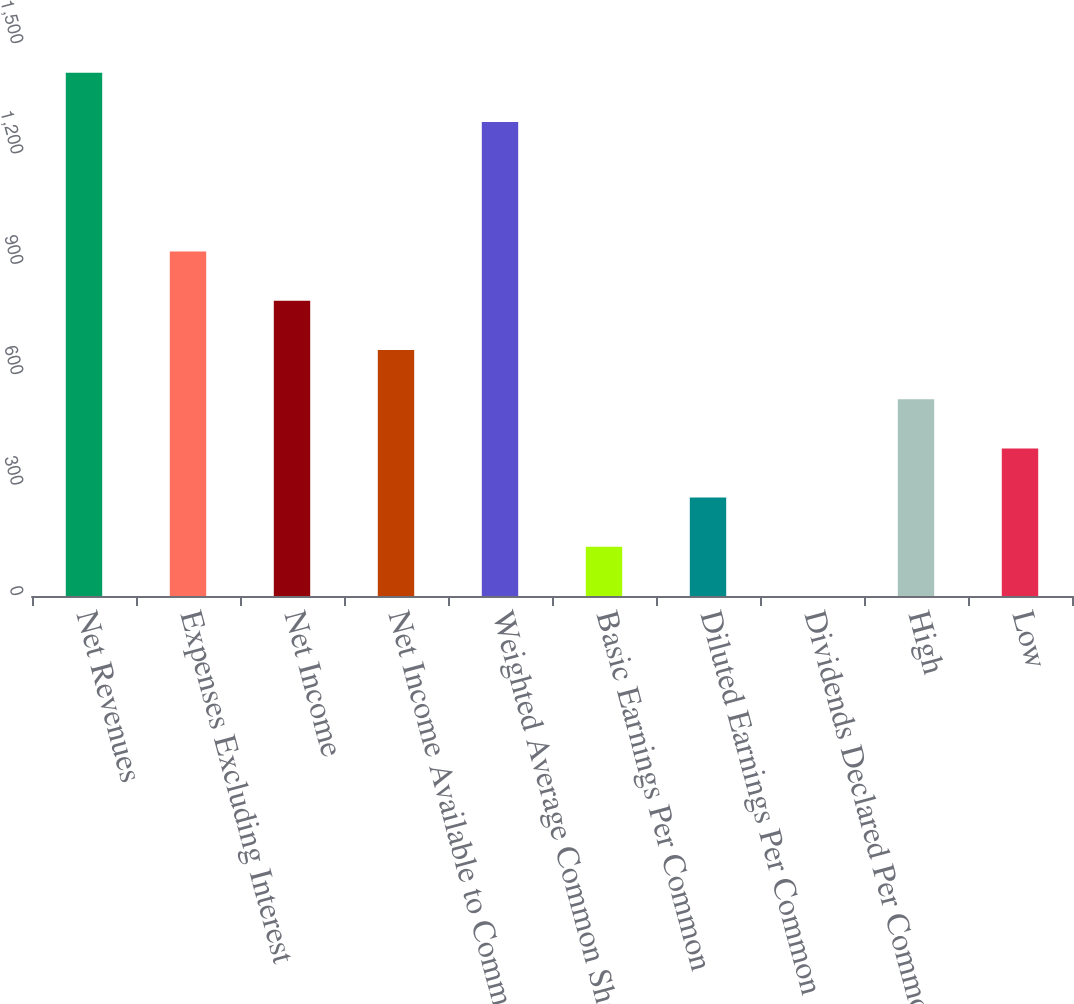Convert chart. <chart><loc_0><loc_0><loc_500><loc_500><bar_chart><fcel>Net Revenues<fcel>Expenses Excluding Interest<fcel>Net Income<fcel>Net Income Available to Common<fcel>Weighted Average Common Shares<fcel>Basic Earnings Per Common<fcel>Diluted Earnings Per Common<fcel>Dividends Declared Per Common<fcel>High<fcel>Low<nl><fcel>1421.69<fcel>935.89<fcel>802.2<fcel>668.51<fcel>1288<fcel>133.75<fcel>267.44<fcel>0.06<fcel>534.82<fcel>401.13<nl></chart> 